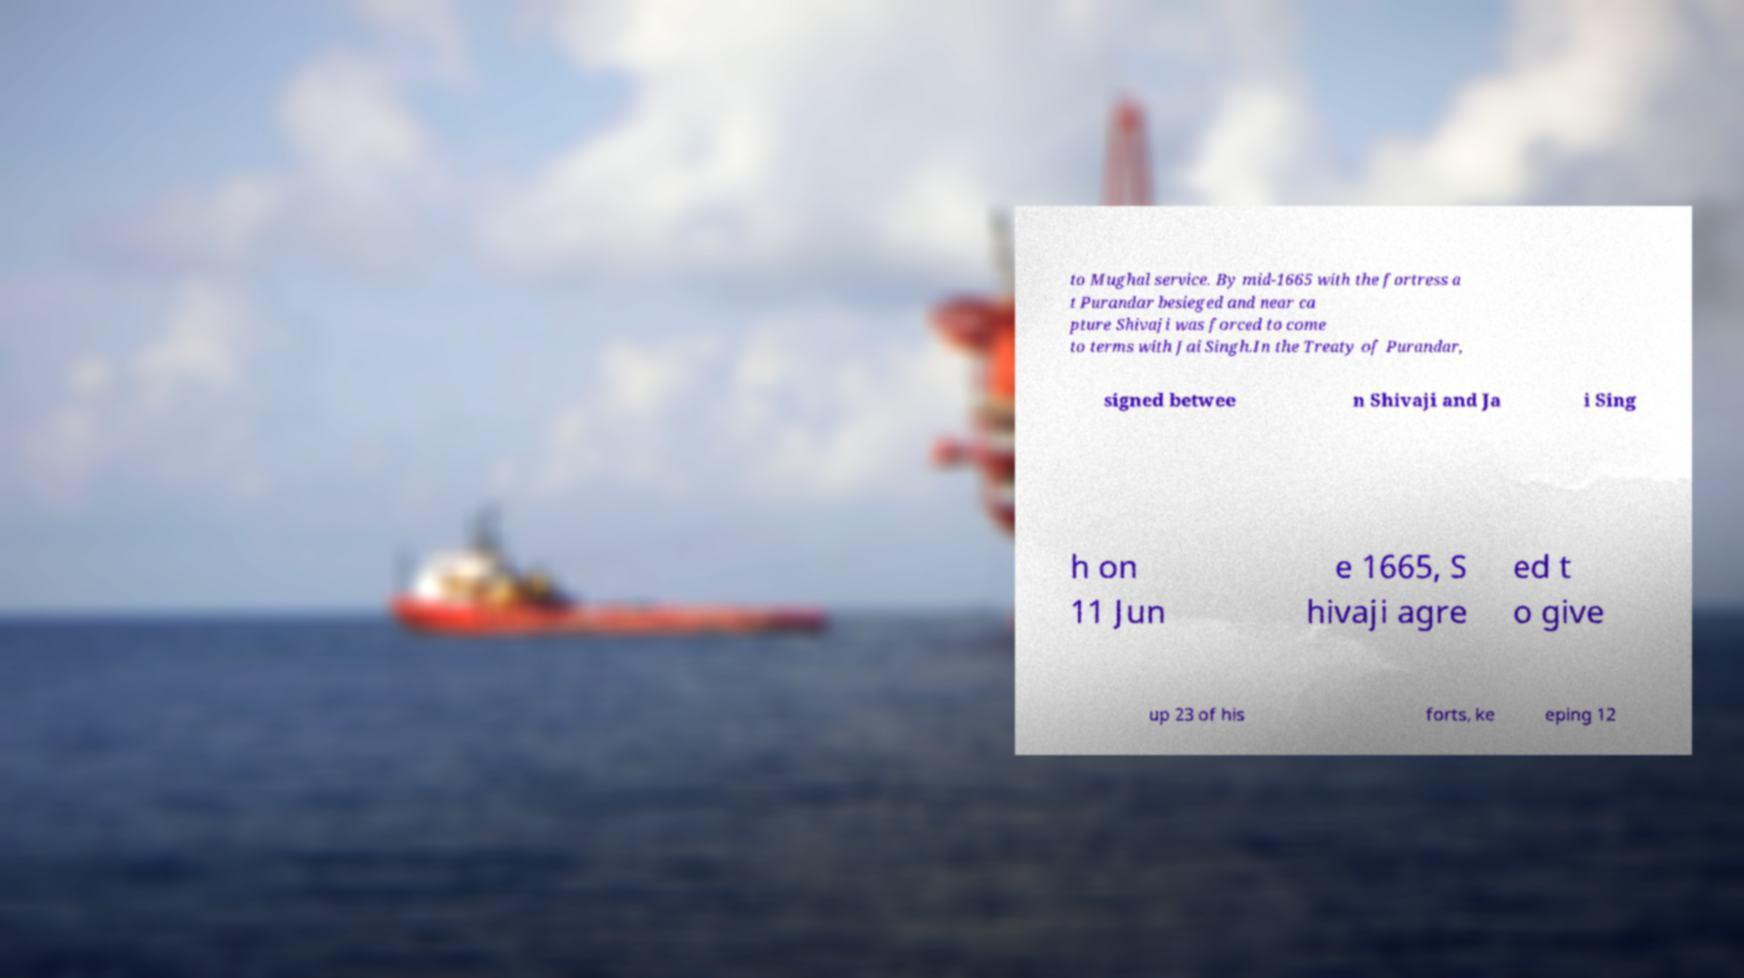Can you accurately transcribe the text from the provided image for me? to Mughal service. By mid-1665 with the fortress a t Purandar besieged and near ca pture Shivaji was forced to come to terms with Jai Singh.In the Treaty of Purandar, signed betwee n Shivaji and Ja i Sing h on 11 Jun e 1665, S hivaji agre ed t o give up 23 of his forts, ke eping 12 